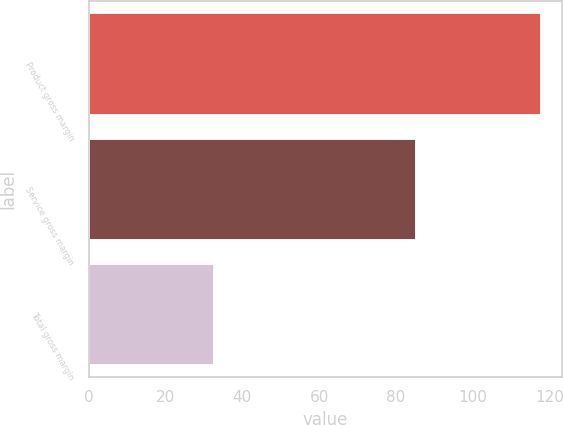Convert chart to OTSL. <chart><loc_0><loc_0><loc_500><loc_500><bar_chart><fcel>Product gross margin<fcel>Service gross margin<fcel>Total gross margin<nl><fcel>117.4<fcel>85<fcel>32.4<nl></chart> 